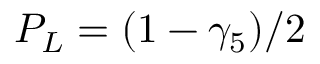Convert formula to latex. <formula><loc_0><loc_0><loc_500><loc_500>P _ { L } = ( 1 - \gamma _ { 5 } ) / 2</formula> 